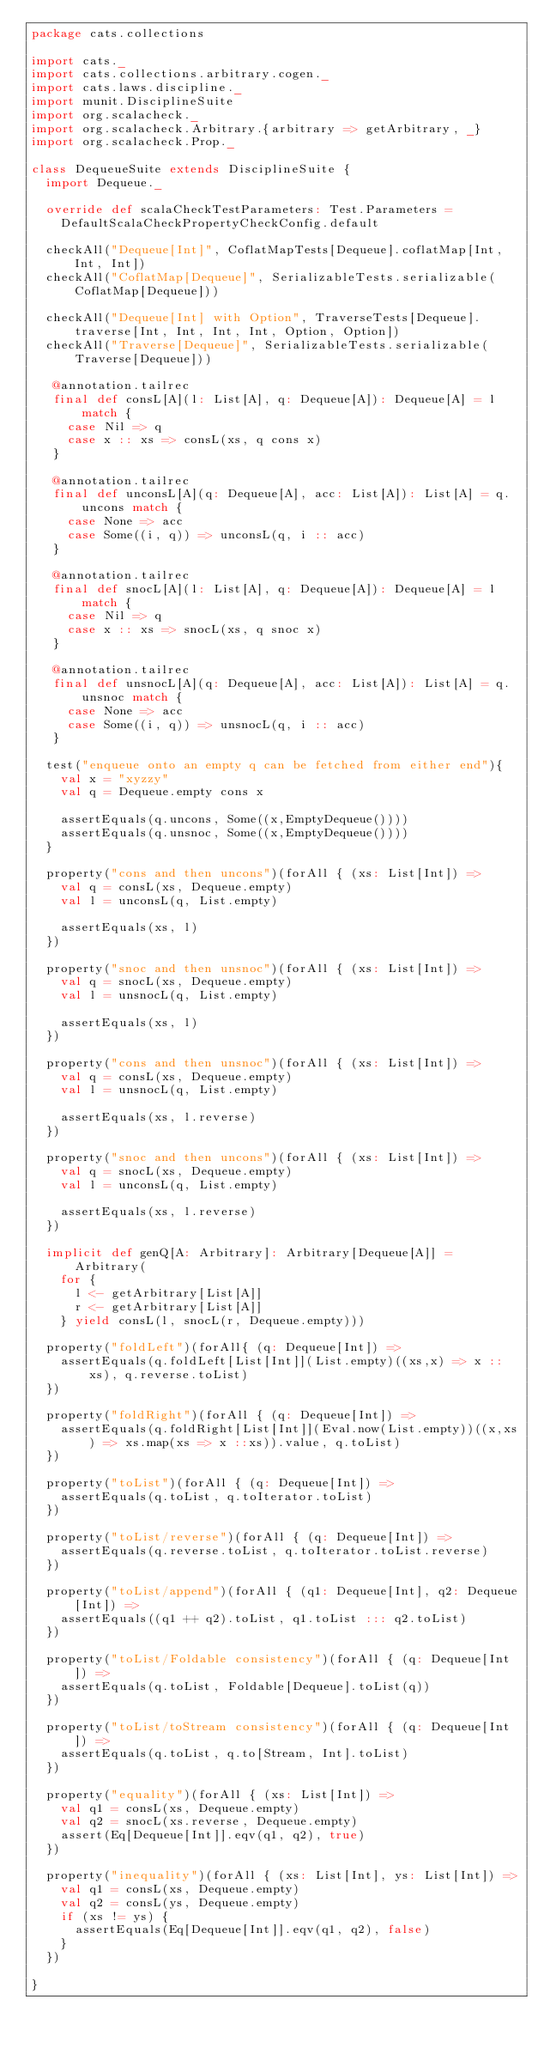Convert code to text. <code><loc_0><loc_0><loc_500><loc_500><_Scala_>package cats.collections

import cats._
import cats.collections.arbitrary.cogen._
import cats.laws.discipline._
import munit.DisciplineSuite
import org.scalacheck._
import org.scalacheck.Arbitrary.{arbitrary => getArbitrary, _}
import org.scalacheck.Prop._

class DequeueSuite extends DisciplineSuite {
  import Dequeue._

  override def scalaCheckTestParameters: Test.Parameters =
    DefaultScalaCheckPropertyCheckConfig.default

  checkAll("Dequeue[Int]", CoflatMapTests[Dequeue].coflatMap[Int, Int, Int])
  checkAll("CoflatMap[Dequeue]", SerializableTests.serializable(CoflatMap[Dequeue]))

  checkAll("Dequeue[Int] with Option", TraverseTests[Dequeue].traverse[Int, Int, Int, Int, Option, Option])
  checkAll("Traverse[Dequeue]", SerializableTests.serializable(Traverse[Dequeue]))

   @annotation.tailrec
   final def consL[A](l: List[A], q: Dequeue[A]): Dequeue[A] = l match {
     case Nil => q
     case x :: xs => consL(xs, q cons x)
   }

   @annotation.tailrec
   final def unconsL[A](q: Dequeue[A], acc: List[A]): List[A] = q.uncons match {
     case None => acc
     case Some((i, q)) => unconsL(q, i :: acc)
   }

   @annotation.tailrec
   final def snocL[A](l: List[A], q: Dequeue[A]): Dequeue[A] = l match {
     case Nil => q
     case x :: xs => snocL(xs, q snoc x)
   }

   @annotation.tailrec
   final def unsnocL[A](q: Dequeue[A], acc: List[A]): List[A] = q.unsnoc match {
     case None => acc
     case Some((i, q)) => unsnocL(q, i :: acc)
   }

  test("enqueue onto an empty q can be fetched from either end"){
    val x = "xyzzy"
    val q = Dequeue.empty cons x

    assertEquals(q.uncons, Some((x,EmptyDequeue())))
    assertEquals(q.unsnoc, Some((x,EmptyDequeue())))
  }

  property("cons and then uncons")(forAll { (xs: List[Int]) =>
    val q = consL(xs, Dequeue.empty)
    val l = unconsL(q, List.empty)

    assertEquals(xs, l)
  })

  property("snoc and then unsnoc")(forAll { (xs: List[Int]) =>
    val q = snocL(xs, Dequeue.empty)
    val l = unsnocL(q, List.empty)

    assertEquals(xs, l)
  })

  property("cons and then unsnoc")(forAll { (xs: List[Int]) =>
    val q = consL(xs, Dequeue.empty)
    val l = unsnocL(q, List.empty)

    assertEquals(xs, l.reverse)
  })

  property("snoc and then uncons")(forAll { (xs: List[Int]) =>
    val q = snocL(xs, Dequeue.empty)
    val l = unconsL(q, List.empty)

    assertEquals(xs, l.reverse)
  })

  implicit def genQ[A: Arbitrary]: Arbitrary[Dequeue[A]] = Arbitrary(
    for {
      l <- getArbitrary[List[A]]
      r <- getArbitrary[List[A]]
    } yield consL(l, snocL(r, Dequeue.empty)))

  property("foldLeft")(forAll{ (q: Dequeue[Int]) =>
    assertEquals(q.foldLeft[List[Int]](List.empty)((xs,x) => x :: xs), q.reverse.toList)
  })

  property("foldRight")(forAll { (q: Dequeue[Int]) =>
    assertEquals(q.foldRight[List[Int]](Eval.now(List.empty))((x,xs) => xs.map(xs => x ::xs)).value, q.toList)
  })

  property("toList")(forAll { (q: Dequeue[Int]) =>
    assertEquals(q.toList, q.toIterator.toList)
  })

  property("toList/reverse")(forAll { (q: Dequeue[Int]) =>
    assertEquals(q.reverse.toList, q.toIterator.toList.reverse)
  })

  property("toList/append")(forAll { (q1: Dequeue[Int], q2: Dequeue[Int]) =>
    assertEquals((q1 ++ q2).toList, q1.toList ::: q2.toList)
  })

  property("toList/Foldable consistency")(forAll { (q: Dequeue[Int]) =>
    assertEquals(q.toList, Foldable[Dequeue].toList(q))
  })

  property("toList/toStream consistency")(forAll { (q: Dequeue[Int]) =>
    assertEquals(q.toList, q.to[Stream, Int].toList)
  })

  property("equality")(forAll { (xs: List[Int]) =>
    val q1 = consL(xs, Dequeue.empty)
    val q2 = snocL(xs.reverse, Dequeue.empty)
    assert(Eq[Dequeue[Int]].eqv(q1, q2), true)
  })

  property("inequality")(forAll { (xs: List[Int], ys: List[Int]) =>
    val q1 = consL(xs, Dequeue.empty)
    val q2 = consL(ys, Dequeue.empty)
    if (xs != ys) {
      assertEquals(Eq[Dequeue[Int]].eqv(q1, q2), false)
    }
  })

}
</code> 